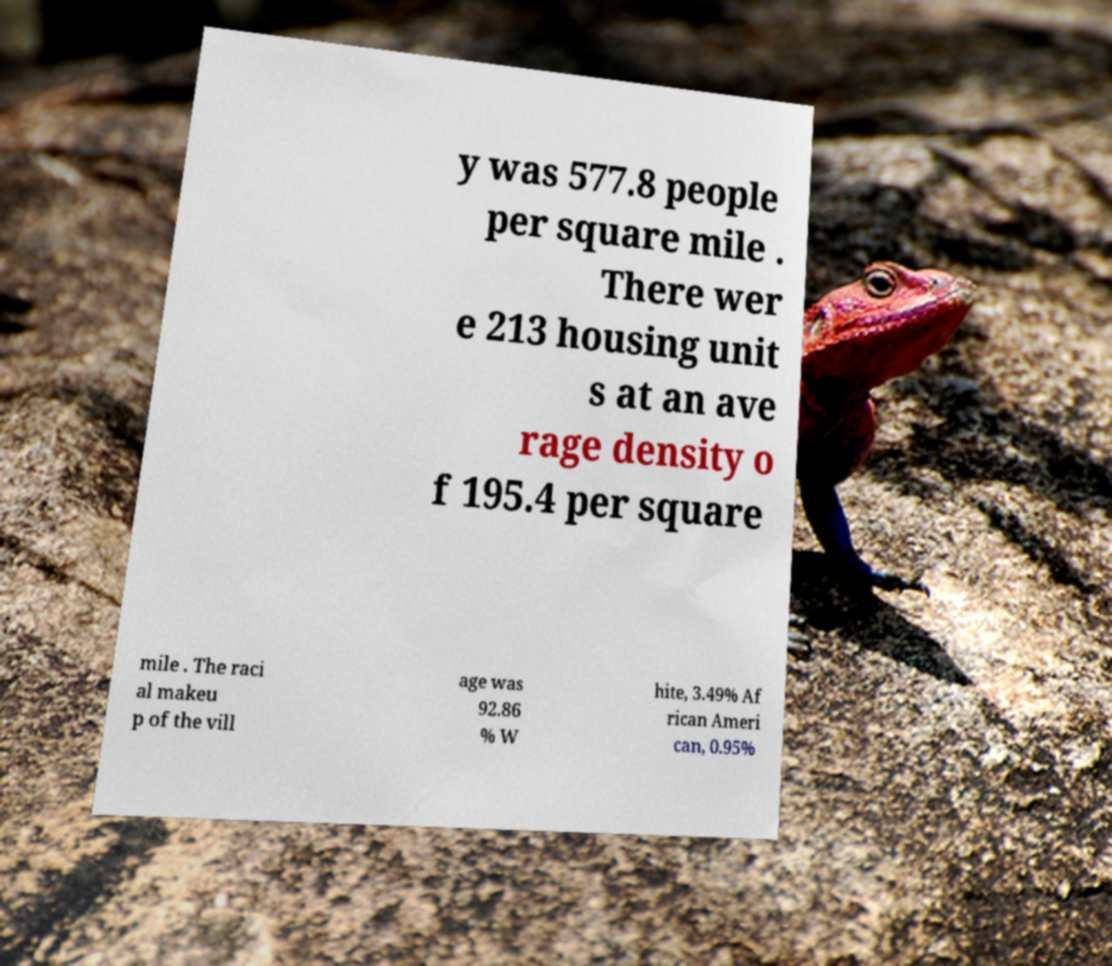Can you accurately transcribe the text from the provided image for me? y was 577.8 people per square mile . There wer e 213 housing unit s at an ave rage density o f 195.4 per square mile . The raci al makeu p of the vill age was 92.86 % W hite, 3.49% Af rican Ameri can, 0.95% 